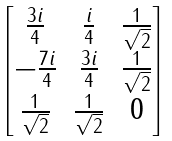Convert formula to latex. <formula><loc_0><loc_0><loc_500><loc_500>\begin{bmatrix} \frac { 3 i } { 4 } & \frac { i } { 4 } & \frac { 1 } { \sqrt { 2 } } \\ - \frac { 7 i } { 4 } & \frac { 3 i } { 4 } & \frac { 1 } { \sqrt { 2 } } \\ \frac { 1 } { \sqrt { 2 } } & \frac { 1 } { \sqrt { 2 } } & 0 \end{bmatrix}</formula> 